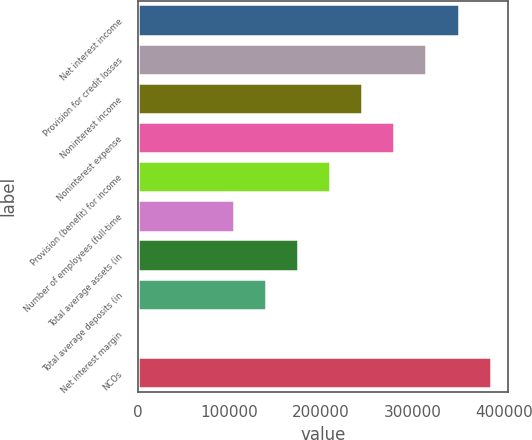Convert chart. <chart><loc_0><loc_0><loc_500><loc_500><bar_chart><fcel>Net interest income<fcel>Provision for credit losses<fcel>Noninterest income<fcel>Noninterest expense<fcel>Provision (benefit) for income<fcel>Number of employees (full-time<fcel>Total average assets (in<fcel>Total average deposits (in<fcel>Net interest margin<fcel>NCOs<nl><fcel>349869<fcel>314882<fcel>244909<fcel>279896<fcel>209922<fcel>104962<fcel>174936<fcel>139949<fcel>2.54<fcel>384856<nl></chart> 